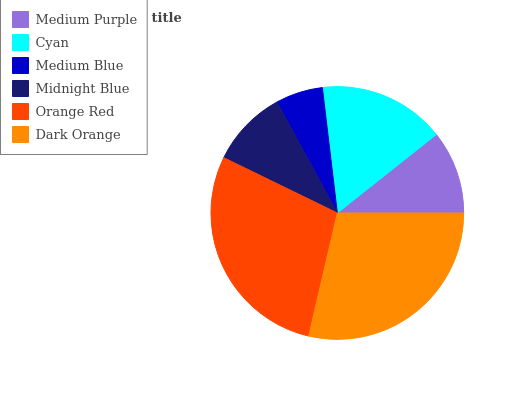Is Medium Blue the minimum?
Answer yes or no. Yes. Is Dark Orange the maximum?
Answer yes or no. Yes. Is Cyan the minimum?
Answer yes or no. No. Is Cyan the maximum?
Answer yes or no. No. Is Cyan greater than Medium Purple?
Answer yes or no. Yes. Is Medium Purple less than Cyan?
Answer yes or no. Yes. Is Medium Purple greater than Cyan?
Answer yes or no. No. Is Cyan less than Medium Purple?
Answer yes or no. No. Is Cyan the high median?
Answer yes or no. Yes. Is Medium Purple the low median?
Answer yes or no. Yes. Is Medium Blue the high median?
Answer yes or no. No. Is Medium Blue the low median?
Answer yes or no. No. 